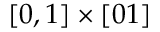Convert formula to latex. <formula><loc_0><loc_0><loc_500><loc_500>[ 0 , 1 ] \times [ 0 1 ]</formula> 